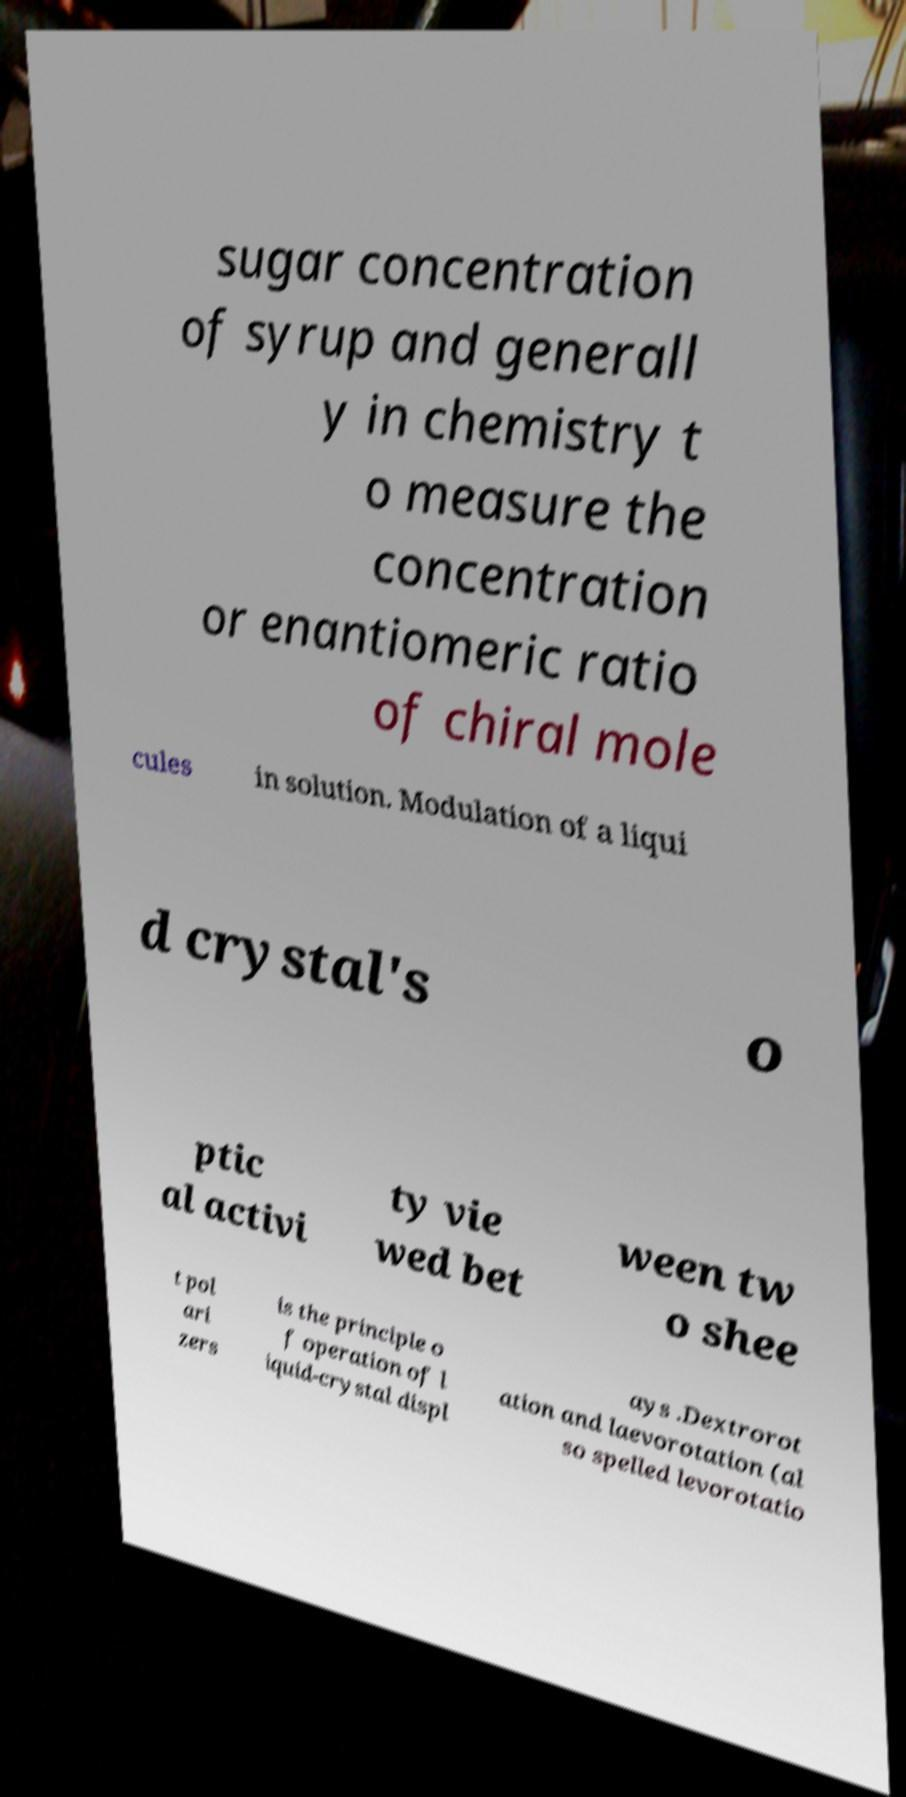Can you accurately transcribe the text from the provided image for me? sugar concentration of syrup and generall y in chemistry t o measure the concentration or enantiomeric ratio of chiral mole cules in solution. Modulation of a liqui d crystal's o ptic al activi ty vie wed bet ween tw o shee t pol ari zers is the principle o f operation of l iquid-crystal displ ays .Dextrorot ation and laevorotation (al so spelled levorotatio 